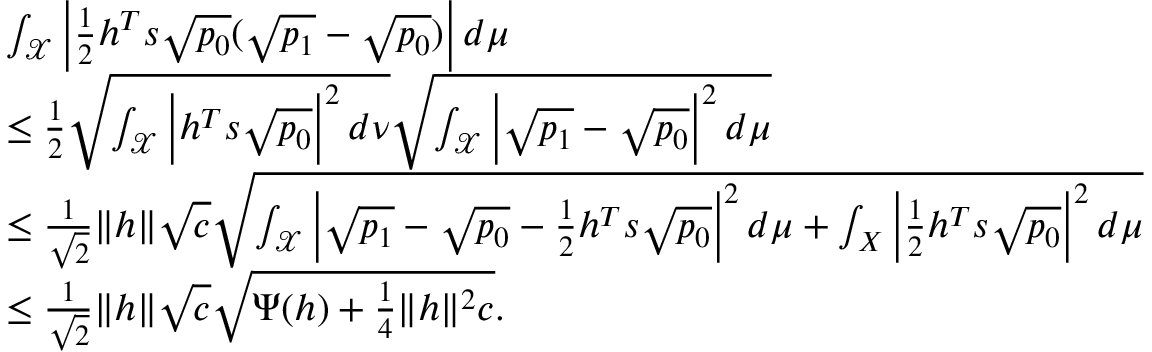<formula> <loc_0><loc_0><loc_500><loc_500>\begin{array} { r l } & { \int _ { \mathcal { X } } \left | \frac { 1 } { 2 } h ^ { T } s \sqrt { p _ { 0 } } ( \sqrt { p _ { 1 } } - \sqrt { p _ { 0 } } ) \right | d \mu } \\ & { \leq \frac { 1 } { 2 } \sqrt { \int _ { \mathcal { X } } \left | h ^ { T } s \sqrt { p _ { 0 } } \right | ^ { 2 } d \nu } \sqrt { \int _ { \mathcal { X } } \left | \sqrt { p _ { 1 } } - \sqrt { p _ { 0 } } \right | ^ { 2 } d \mu } } \\ & { \leq \frac { 1 } { \sqrt { 2 } } \| h \| \sqrt { c } \sqrt { \int _ { \mathcal { X } } \left | \sqrt { p _ { 1 } } - \sqrt { p _ { 0 } } - \frac { 1 } { 2 } h ^ { T } s \sqrt { p _ { 0 } } \right | ^ { 2 } d \mu + \int _ { X } \left | \frac { 1 } { 2 } h ^ { T } s \sqrt { p _ { 0 } } \right | ^ { 2 } d \mu } } \\ & { \leq \frac { 1 } { \sqrt { 2 } } \| h \| \sqrt { c } \sqrt { \Psi ( h ) + \frac { 1 } { 4 } \| h \| ^ { 2 } c } . } \end{array}</formula> 